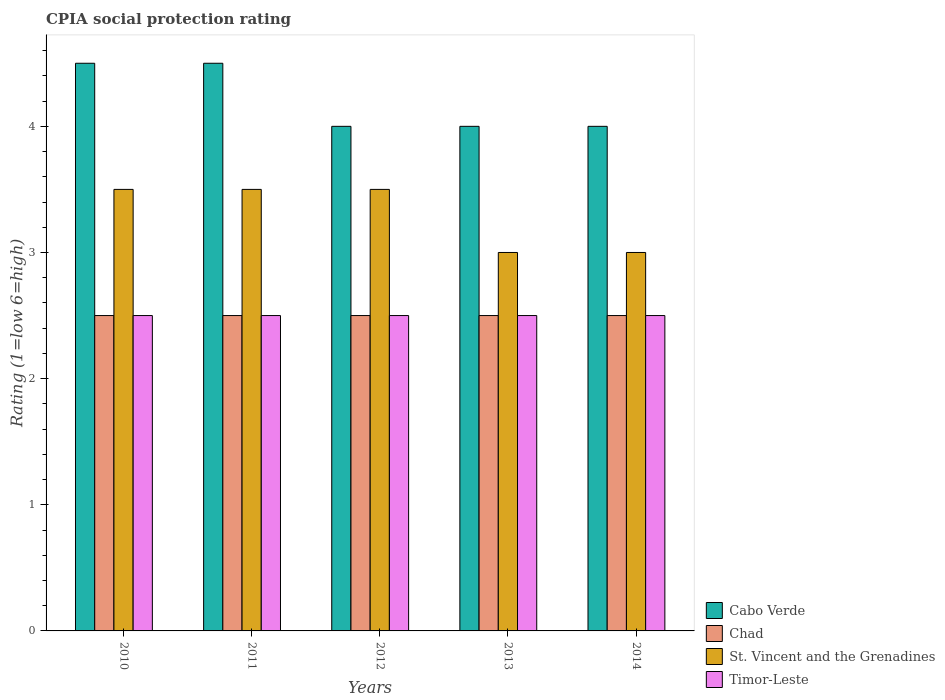How many different coloured bars are there?
Your answer should be very brief. 4. Are the number of bars per tick equal to the number of legend labels?
Your answer should be compact. Yes. In how many cases, is the number of bars for a given year not equal to the number of legend labels?
Your answer should be compact. 0. What is the CPIA rating in Timor-Leste in 2010?
Offer a very short reply. 2.5. Across all years, what is the maximum CPIA rating in St. Vincent and the Grenadines?
Offer a terse response. 3.5. In which year was the CPIA rating in Chad maximum?
Offer a very short reply. 2010. In which year was the CPIA rating in Chad minimum?
Ensure brevity in your answer.  2010. What is the difference between the CPIA rating in St. Vincent and the Grenadines in 2012 and that in 2014?
Make the answer very short. 0.5. What is the difference between the CPIA rating in St. Vincent and the Grenadines in 2012 and the CPIA rating in Chad in 2013?
Your answer should be very brief. 1. What is the average CPIA rating in Timor-Leste per year?
Make the answer very short. 2.5. In the year 2011, what is the difference between the CPIA rating in St. Vincent and the Grenadines and CPIA rating in Cabo Verde?
Your response must be concise. -1. Is the difference between the CPIA rating in St. Vincent and the Grenadines in 2010 and 2013 greater than the difference between the CPIA rating in Cabo Verde in 2010 and 2013?
Your answer should be very brief. No. What is the difference between the highest and the second highest CPIA rating in Chad?
Your answer should be compact. 0. What is the difference between the highest and the lowest CPIA rating in Timor-Leste?
Provide a succinct answer. 0. Is the sum of the CPIA rating in Cabo Verde in 2010 and 2013 greater than the maximum CPIA rating in St. Vincent and the Grenadines across all years?
Your answer should be compact. Yes. Is it the case that in every year, the sum of the CPIA rating in Chad and CPIA rating in St. Vincent and the Grenadines is greater than the sum of CPIA rating in Cabo Verde and CPIA rating in Timor-Leste?
Provide a succinct answer. No. What does the 4th bar from the left in 2014 represents?
Provide a short and direct response. Timor-Leste. What does the 3rd bar from the right in 2011 represents?
Offer a terse response. Chad. Is it the case that in every year, the sum of the CPIA rating in Chad and CPIA rating in St. Vincent and the Grenadines is greater than the CPIA rating in Timor-Leste?
Keep it short and to the point. Yes. How many bars are there?
Ensure brevity in your answer.  20. What is the difference between two consecutive major ticks on the Y-axis?
Offer a terse response. 1. Are the values on the major ticks of Y-axis written in scientific E-notation?
Offer a terse response. No. Does the graph contain grids?
Your answer should be very brief. No. How are the legend labels stacked?
Give a very brief answer. Vertical. What is the title of the graph?
Offer a terse response. CPIA social protection rating. What is the label or title of the X-axis?
Make the answer very short. Years. What is the label or title of the Y-axis?
Your answer should be very brief. Rating (1=low 6=high). What is the Rating (1=low 6=high) of Cabo Verde in 2010?
Keep it short and to the point. 4.5. What is the Rating (1=low 6=high) in Chad in 2010?
Offer a terse response. 2.5. What is the Rating (1=low 6=high) of Timor-Leste in 2010?
Ensure brevity in your answer.  2.5. What is the Rating (1=low 6=high) in Cabo Verde in 2011?
Make the answer very short. 4.5. What is the Rating (1=low 6=high) of St. Vincent and the Grenadines in 2011?
Your answer should be compact. 3.5. What is the Rating (1=low 6=high) of Timor-Leste in 2011?
Give a very brief answer. 2.5. What is the Rating (1=low 6=high) of Cabo Verde in 2012?
Keep it short and to the point. 4. What is the Rating (1=low 6=high) in Chad in 2012?
Your response must be concise. 2.5. What is the Rating (1=low 6=high) in St. Vincent and the Grenadines in 2012?
Ensure brevity in your answer.  3.5. What is the Rating (1=low 6=high) in Cabo Verde in 2013?
Your answer should be very brief. 4. What is the Rating (1=low 6=high) in Chad in 2013?
Provide a succinct answer. 2.5. What is the Rating (1=low 6=high) in St. Vincent and the Grenadines in 2013?
Your answer should be very brief. 3. What is the Rating (1=low 6=high) in Cabo Verde in 2014?
Provide a short and direct response. 4. What is the Rating (1=low 6=high) in Chad in 2014?
Offer a terse response. 2.5. What is the Rating (1=low 6=high) of St. Vincent and the Grenadines in 2014?
Give a very brief answer. 3. Across all years, what is the maximum Rating (1=low 6=high) of Cabo Verde?
Your answer should be very brief. 4.5. Across all years, what is the maximum Rating (1=low 6=high) of Timor-Leste?
Ensure brevity in your answer.  2.5. Across all years, what is the minimum Rating (1=low 6=high) in Chad?
Your answer should be compact. 2.5. Across all years, what is the minimum Rating (1=low 6=high) in Timor-Leste?
Offer a terse response. 2.5. What is the total Rating (1=low 6=high) in Chad in the graph?
Give a very brief answer. 12.5. What is the difference between the Rating (1=low 6=high) in Cabo Verde in 2010 and that in 2011?
Ensure brevity in your answer.  0. What is the difference between the Rating (1=low 6=high) of Timor-Leste in 2010 and that in 2011?
Your response must be concise. 0. What is the difference between the Rating (1=low 6=high) of Cabo Verde in 2010 and that in 2012?
Your answer should be compact. 0.5. What is the difference between the Rating (1=low 6=high) of Chad in 2010 and that in 2012?
Give a very brief answer. 0. What is the difference between the Rating (1=low 6=high) in Cabo Verde in 2010 and that in 2014?
Provide a succinct answer. 0.5. What is the difference between the Rating (1=low 6=high) in Chad in 2010 and that in 2014?
Offer a very short reply. 0. What is the difference between the Rating (1=low 6=high) of St. Vincent and the Grenadines in 2011 and that in 2013?
Ensure brevity in your answer.  0.5. What is the difference between the Rating (1=low 6=high) in Timor-Leste in 2011 and that in 2014?
Your answer should be very brief. 0. What is the difference between the Rating (1=low 6=high) in Cabo Verde in 2012 and that in 2013?
Your answer should be very brief. 0. What is the difference between the Rating (1=low 6=high) in Chad in 2012 and that in 2013?
Provide a short and direct response. 0. What is the difference between the Rating (1=low 6=high) of St. Vincent and the Grenadines in 2012 and that in 2013?
Your answer should be very brief. 0.5. What is the difference between the Rating (1=low 6=high) of Cabo Verde in 2012 and that in 2014?
Ensure brevity in your answer.  0. What is the difference between the Rating (1=low 6=high) of Chad in 2012 and that in 2014?
Your answer should be very brief. 0. What is the difference between the Rating (1=low 6=high) of Cabo Verde in 2013 and that in 2014?
Ensure brevity in your answer.  0. What is the difference between the Rating (1=low 6=high) of St. Vincent and the Grenadines in 2013 and that in 2014?
Your answer should be very brief. 0. What is the difference between the Rating (1=low 6=high) in Cabo Verde in 2010 and the Rating (1=low 6=high) in St. Vincent and the Grenadines in 2011?
Your answer should be compact. 1. What is the difference between the Rating (1=low 6=high) of Chad in 2010 and the Rating (1=low 6=high) of Timor-Leste in 2011?
Your answer should be very brief. 0. What is the difference between the Rating (1=low 6=high) in Cabo Verde in 2010 and the Rating (1=low 6=high) in St. Vincent and the Grenadines in 2012?
Offer a very short reply. 1. What is the difference between the Rating (1=low 6=high) of Cabo Verde in 2010 and the Rating (1=low 6=high) of Timor-Leste in 2012?
Provide a succinct answer. 2. What is the difference between the Rating (1=low 6=high) in St. Vincent and the Grenadines in 2010 and the Rating (1=low 6=high) in Timor-Leste in 2012?
Give a very brief answer. 1. What is the difference between the Rating (1=low 6=high) of Cabo Verde in 2010 and the Rating (1=low 6=high) of Chad in 2013?
Provide a short and direct response. 2. What is the difference between the Rating (1=low 6=high) of Cabo Verde in 2010 and the Rating (1=low 6=high) of St. Vincent and the Grenadines in 2013?
Give a very brief answer. 1.5. What is the difference between the Rating (1=low 6=high) in Chad in 2010 and the Rating (1=low 6=high) in St. Vincent and the Grenadines in 2013?
Give a very brief answer. -0.5. What is the difference between the Rating (1=low 6=high) in Chad in 2010 and the Rating (1=low 6=high) in Timor-Leste in 2013?
Your response must be concise. 0. What is the difference between the Rating (1=low 6=high) in Cabo Verde in 2010 and the Rating (1=low 6=high) in Chad in 2014?
Your answer should be very brief. 2. What is the difference between the Rating (1=low 6=high) of Cabo Verde in 2010 and the Rating (1=low 6=high) of Timor-Leste in 2014?
Provide a succinct answer. 2. What is the difference between the Rating (1=low 6=high) in Chad in 2010 and the Rating (1=low 6=high) in St. Vincent and the Grenadines in 2014?
Your response must be concise. -0.5. What is the difference between the Rating (1=low 6=high) of Cabo Verde in 2011 and the Rating (1=low 6=high) of Chad in 2012?
Make the answer very short. 2. What is the difference between the Rating (1=low 6=high) in Chad in 2011 and the Rating (1=low 6=high) in St. Vincent and the Grenadines in 2012?
Keep it short and to the point. -1. What is the difference between the Rating (1=low 6=high) of Chad in 2011 and the Rating (1=low 6=high) of Timor-Leste in 2012?
Offer a terse response. 0. What is the difference between the Rating (1=low 6=high) in St. Vincent and the Grenadines in 2011 and the Rating (1=low 6=high) in Timor-Leste in 2012?
Offer a very short reply. 1. What is the difference between the Rating (1=low 6=high) in Cabo Verde in 2011 and the Rating (1=low 6=high) in Chad in 2013?
Ensure brevity in your answer.  2. What is the difference between the Rating (1=low 6=high) of Cabo Verde in 2011 and the Rating (1=low 6=high) of Timor-Leste in 2013?
Offer a very short reply. 2. What is the difference between the Rating (1=low 6=high) of Cabo Verde in 2011 and the Rating (1=low 6=high) of St. Vincent and the Grenadines in 2014?
Provide a succinct answer. 1.5. What is the difference between the Rating (1=low 6=high) of Chad in 2011 and the Rating (1=low 6=high) of St. Vincent and the Grenadines in 2014?
Make the answer very short. -0.5. What is the difference between the Rating (1=low 6=high) of St. Vincent and the Grenadines in 2011 and the Rating (1=low 6=high) of Timor-Leste in 2014?
Provide a succinct answer. 1. What is the difference between the Rating (1=low 6=high) of Cabo Verde in 2012 and the Rating (1=low 6=high) of Chad in 2013?
Keep it short and to the point. 1.5. What is the difference between the Rating (1=low 6=high) of Cabo Verde in 2012 and the Rating (1=low 6=high) of St. Vincent and the Grenadines in 2013?
Make the answer very short. 1. What is the difference between the Rating (1=low 6=high) in Chad in 2012 and the Rating (1=low 6=high) in St. Vincent and the Grenadines in 2013?
Provide a short and direct response. -0.5. What is the difference between the Rating (1=low 6=high) of Chad in 2012 and the Rating (1=low 6=high) of Timor-Leste in 2013?
Give a very brief answer. 0. What is the difference between the Rating (1=low 6=high) of Cabo Verde in 2012 and the Rating (1=low 6=high) of Chad in 2014?
Make the answer very short. 1.5. What is the difference between the Rating (1=low 6=high) in Cabo Verde in 2012 and the Rating (1=low 6=high) in St. Vincent and the Grenadines in 2014?
Provide a succinct answer. 1. What is the difference between the Rating (1=low 6=high) in Chad in 2012 and the Rating (1=low 6=high) in St. Vincent and the Grenadines in 2014?
Your answer should be very brief. -0.5. What is the difference between the Rating (1=low 6=high) in Cabo Verde in 2013 and the Rating (1=low 6=high) in Chad in 2014?
Make the answer very short. 1.5. What is the difference between the Rating (1=low 6=high) of Cabo Verde in 2013 and the Rating (1=low 6=high) of St. Vincent and the Grenadines in 2014?
Provide a short and direct response. 1. What is the difference between the Rating (1=low 6=high) in Cabo Verde in 2013 and the Rating (1=low 6=high) in Timor-Leste in 2014?
Offer a terse response. 1.5. What is the difference between the Rating (1=low 6=high) of Chad in 2013 and the Rating (1=low 6=high) of St. Vincent and the Grenadines in 2014?
Keep it short and to the point. -0.5. What is the difference between the Rating (1=low 6=high) in Chad in 2013 and the Rating (1=low 6=high) in Timor-Leste in 2014?
Offer a terse response. 0. What is the average Rating (1=low 6=high) of St. Vincent and the Grenadines per year?
Provide a succinct answer. 3.3. What is the average Rating (1=low 6=high) of Timor-Leste per year?
Provide a succinct answer. 2.5. In the year 2010, what is the difference between the Rating (1=low 6=high) in Cabo Verde and Rating (1=low 6=high) in Timor-Leste?
Give a very brief answer. 2. In the year 2011, what is the difference between the Rating (1=low 6=high) in Chad and Rating (1=low 6=high) in Timor-Leste?
Make the answer very short. 0. In the year 2011, what is the difference between the Rating (1=low 6=high) of St. Vincent and the Grenadines and Rating (1=low 6=high) of Timor-Leste?
Offer a terse response. 1. In the year 2012, what is the difference between the Rating (1=low 6=high) of Cabo Verde and Rating (1=low 6=high) of Chad?
Keep it short and to the point. 1.5. In the year 2012, what is the difference between the Rating (1=low 6=high) of Chad and Rating (1=low 6=high) of Timor-Leste?
Your answer should be very brief. 0. In the year 2013, what is the difference between the Rating (1=low 6=high) of Cabo Verde and Rating (1=low 6=high) of Chad?
Your answer should be very brief. 1.5. In the year 2013, what is the difference between the Rating (1=low 6=high) in Cabo Verde and Rating (1=low 6=high) in St. Vincent and the Grenadines?
Provide a succinct answer. 1. In the year 2013, what is the difference between the Rating (1=low 6=high) in Cabo Verde and Rating (1=low 6=high) in Timor-Leste?
Ensure brevity in your answer.  1.5. In the year 2013, what is the difference between the Rating (1=low 6=high) of Chad and Rating (1=low 6=high) of St. Vincent and the Grenadines?
Your response must be concise. -0.5. In the year 2013, what is the difference between the Rating (1=low 6=high) in St. Vincent and the Grenadines and Rating (1=low 6=high) in Timor-Leste?
Your response must be concise. 0.5. In the year 2014, what is the difference between the Rating (1=low 6=high) of Cabo Verde and Rating (1=low 6=high) of Chad?
Offer a very short reply. 1.5. In the year 2014, what is the difference between the Rating (1=low 6=high) of Cabo Verde and Rating (1=low 6=high) of Timor-Leste?
Offer a terse response. 1.5. What is the ratio of the Rating (1=low 6=high) in Cabo Verde in 2010 to that in 2011?
Your answer should be compact. 1. What is the ratio of the Rating (1=low 6=high) of Chad in 2010 to that in 2011?
Your response must be concise. 1. What is the ratio of the Rating (1=low 6=high) in St. Vincent and the Grenadines in 2010 to that in 2011?
Provide a short and direct response. 1. What is the ratio of the Rating (1=low 6=high) of Chad in 2010 to that in 2012?
Your answer should be compact. 1. What is the ratio of the Rating (1=low 6=high) of St. Vincent and the Grenadines in 2010 to that in 2012?
Your answer should be very brief. 1. What is the ratio of the Rating (1=low 6=high) in Timor-Leste in 2010 to that in 2012?
Offer a very short reply. 1. What is the ratio of the Rating (1=low 6=high) in Cabo Verde in 2010 to that in 2013?
Your response must be concise. 1.12. What is the ratio of the Rating (1=low 6=high) of St. Vincent and the Grenadines in 2010 to that in 2013?
Provide a succinct answer. 1.17. What is the ratio of the Rating (1=low 6=high) in Cabo Verde in 2010 to that in 2014?
Your response must be concise. 1.12. What is the ratio of the Rating (1=low 6=high) in Cabo Verde in 2011 to that in 2012?
Offer a terse response. 1.12. What is the ratio of the Rating (1=low 6=high) of Cabo Verde in 2011 to that in 2013?
Provide a succinct answer. 1.12. What is the ratio of the Rating (1=low 6=high) of Chad in 2011 to that in 2013?
Ensure brevity in your answer.  1. What is the ratio of the Rating (1=low 6=high) in Cabo Verde in 2011 to that in 2014?
Ensure brevity in your answer.  1.12. What is the ratio of the Rating (1=low 6=high) of St. Vincent and the Grenadines in 2011 to that in 2014?
Your answer should be compact. 1.17. What is the ratio of the Rating (1=low 6=high) of Timor-Leste in 2011 to that in 2014?
Offer a terse response. 1. What is the ratio of the Rating (1=low 6=high) in Chad in 2012 to that in 2013?
Ensure brevity in your answer.  1. What is the ratio of the Rating (1=low 6=high) in St. Vincent and the Grenadines in 2012 to that in 2013?
Provide a short and direct response. 1.17. What is the ratio of the Rating (1=low 6=high) in St. Vincent and the Grenadines in 2012 to that in 2014?
Provide a short and direct response. 1.17. What is the ratio of the Rating (1=low 6=high) of Cabo Verde in 2013 to that in 2014?
Keep it short and to the point. 1. What is the difference between the highest and the second highest Rating (1=low 6=high) of St. Vincent and the Grenadines?
Your answer should be compact. 0. What is the difference between the highest and the lowest Rating (1=low 6=high) in Chad?
Offer a terse response. 0. What is the difference between the highest and the lowest Rating (1=low 6=high) in St. Vincent and the Grenadines?
Offer a terse response. 0.5. What is the difference between the highest and the lowest Rating (1=low 6=high) of Timor-Leste?
Your response must be concise. 0. 